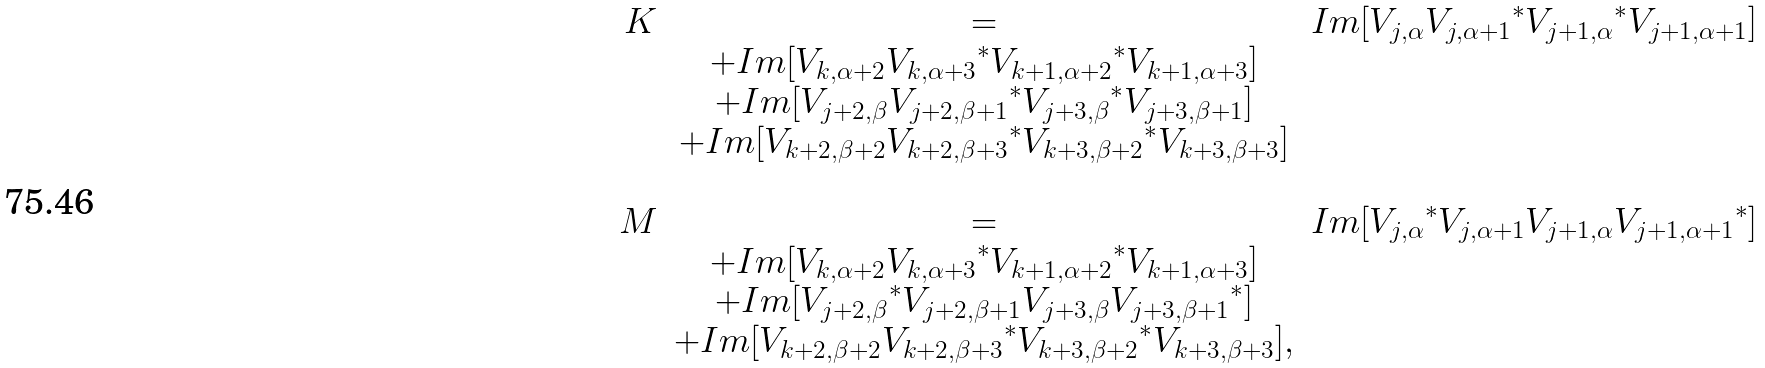<formula> <loc_0><loc_0><loc_500><loc_500>\begin{array} { r c l } K & = & I m [ V _ { j , \alpha } { V _ { j , \alpha + 1 } } ^ { * } { V _ { j + 1 , \alpha } } ^ { * } V _ { j + 1 , \alpha + 1 } ] \\ & + I m [ V _ { k , \alpha + 2 } { V _ { k , \alpha + 3 } } ^ { * } { V _ { k + 1 , \alpha + 2 } } ^ { * } V _ { k + 1 , \alpha + 3 } ] \\ & + I m [ V _ { j + 2 , \beta } { V _ { j + 2 , \beta + 1 } } ^ { * } { V _ { j + 3 , \beta } } ^ { * } V _ { j + 3 , \beta + 1 } ] \\ & + I m [ V _ { k + 2 , \beta + 2 } { V _ { k + 2 , \beta + 3 } } ^ { * } { V _ { k + 3 , \beta + 2 } } ^ { * } V _ { k + 3 , \beta + 3 } ] \\ & & \\ M & = & I m [ { V _ { j , \alpha } } ^ { * } V _ { j , \alpha + 1 } V _ { j + 1 , \alpha } { V _ { j + 1 , \alpha + 1 } } ^ { * } ] \\ & + I m [ V _ { k , \alpha + 2 } { V _ { k , \alpha + 3 } } ^ { * } { V _ { k + 1 , \alpha + 2 } } ^ { * } V _ { k + 1 , \alpha + 3 } ] \\ & + I m [ { V _ { j + 2 , \beta } } ^ { * } V _ { j + 2 , \beta + 1 } V _ { j + 3 , \beta } { V _ { j + 3 , \beta + 1 } } ^ { * } ] \\ & + I m [ V _ { k + 2 , \beta + 2 } { V _ { k + 2 , \beta + 3 } } ^ { * } { V _ { k + 3 , \beta + 2 } } ^ { * } V _ { k + 3 , \beta + 3 } ] , \\ & & \end{array}</formula> 